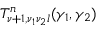<formula> <loc_0><loc_0><loc_500><loc_500>T _ { \nu + 1 , \nu _ { 1 } \nu _ { 2 } l } ^ { n } ( \gamma _ { 1 } , \gamma _ { 2 } )</formula> 